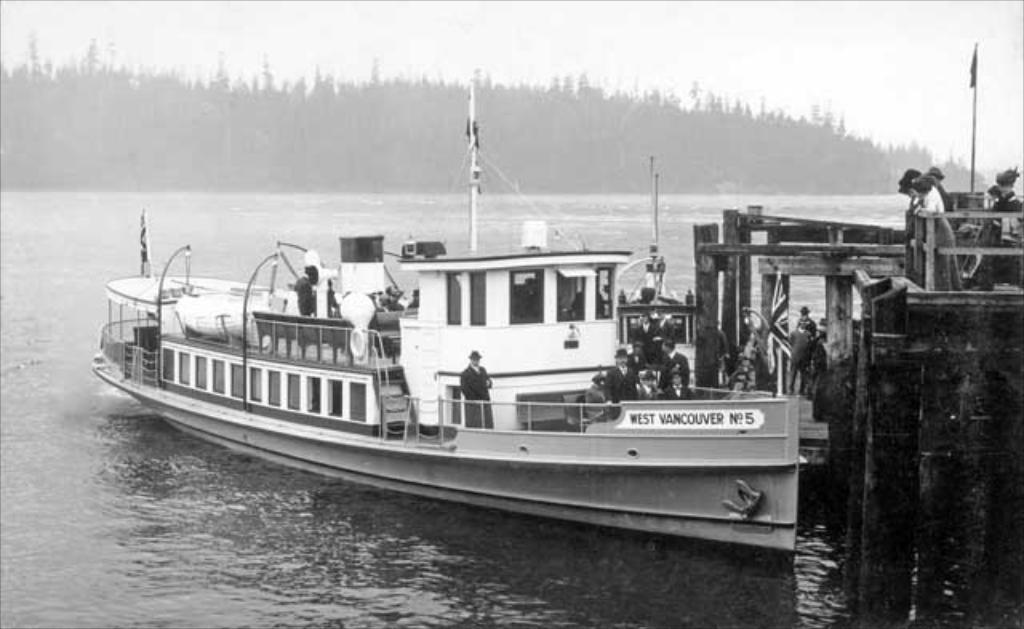Provide a one-sentence caption for the provided image. The West Vancouver No 5 is docked at the pier. 